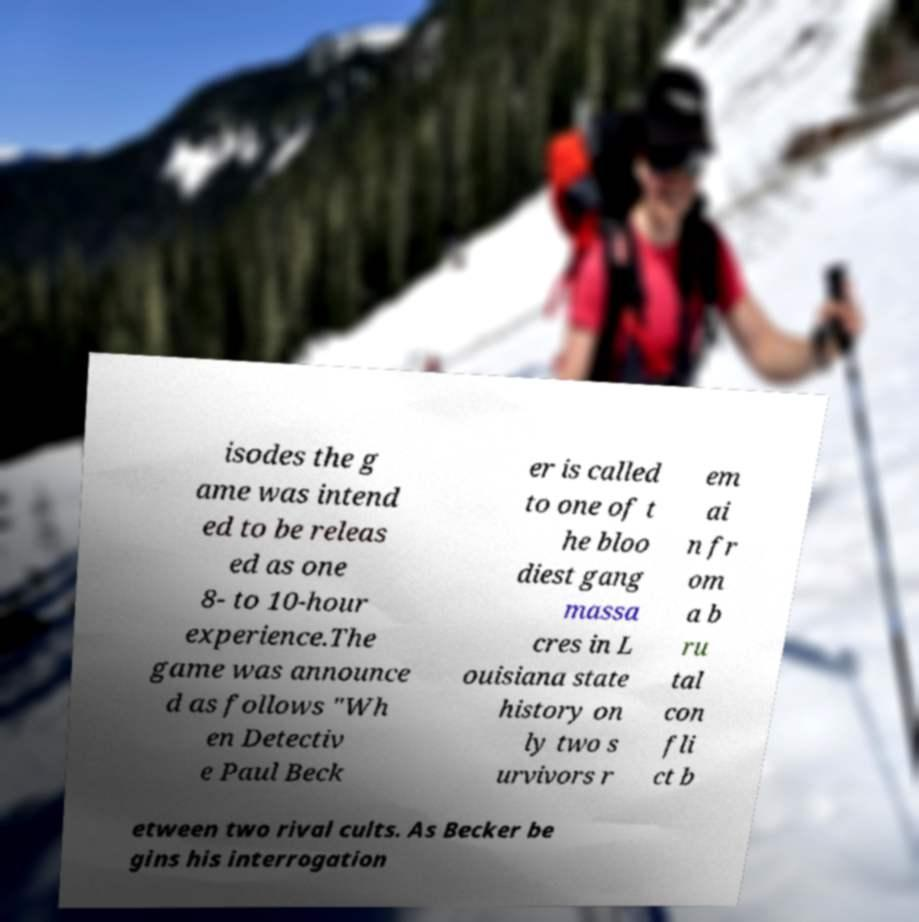Please identify and transcribe the text found in this image. isodes the g ame was intend ed to be releas ed as one 8- to 10-hour experience.The game was announce d as follows "Wh en Detectiv e Paul Beck er is called to one of t he bloo diest gang massa cres in L ouisiana state history on ly two s urvivors r em ai n fr om a b ru tal con fli ct b etween two rival cults. As Becker be gins his interrogation 